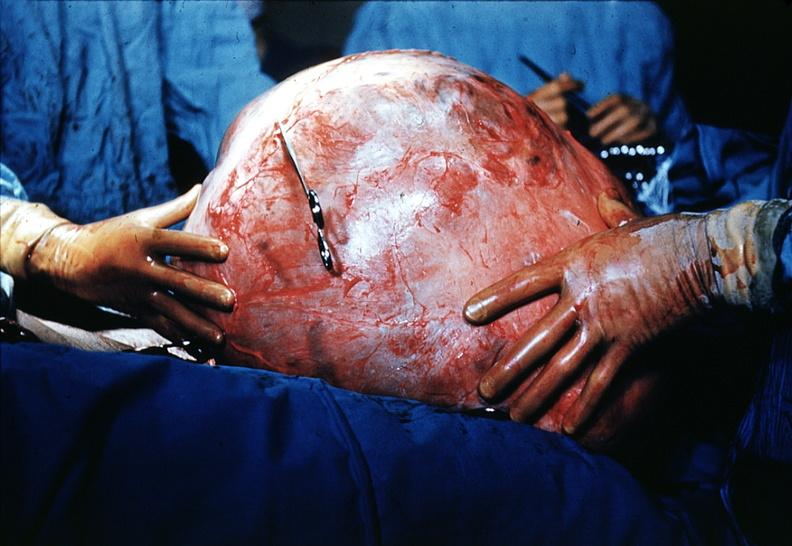what does this image show?
Answer the question using a single word or phrase. Massive lesion taken at surgery size of basketball very good 